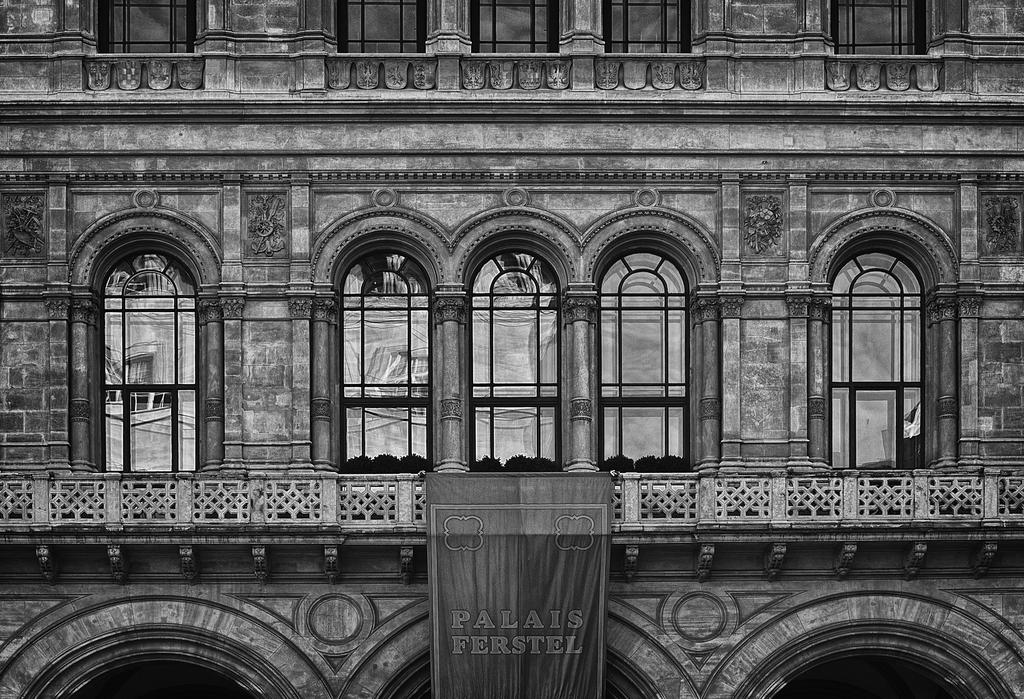What is the main structure in the image? There is a building in the image. What is located at the bottom of the image? There is a banner at the bottom of the image. What can be read on the banner? There is text on the banner. What feature can be seen on the building? The building has windows. What is the color scheme of the image? The image is black and white. What type of trouble is the flesh experiencing in the image? There is no flesh or trouble depicted in the image; it features a building and a banner with text. 